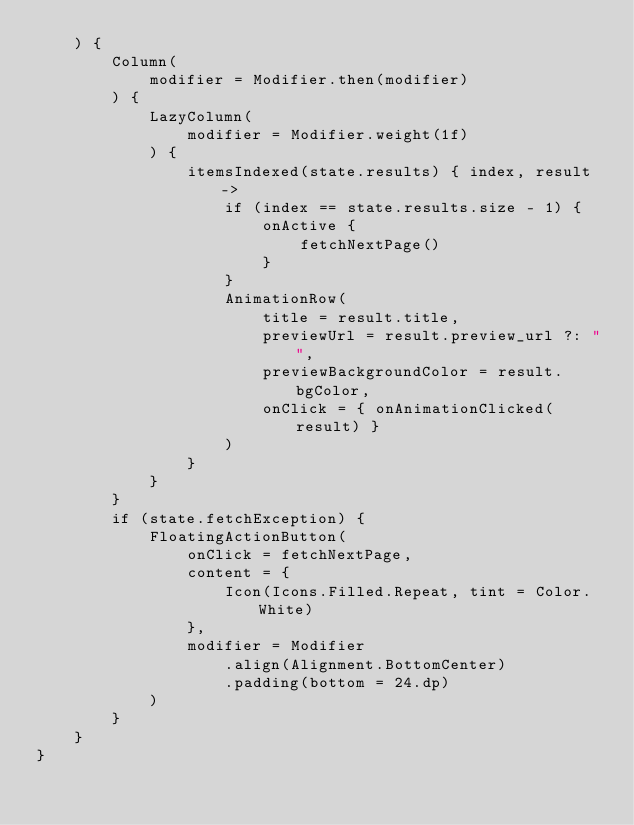<code> <loc_0><loc_0><loc_500><loc_500><_Kotlin_>    ) {
        Column(
            modifier = Modifier.then(modifier)
        ) {
            LazyColumn(
                modifier = Modifier.weight(1f)
            ) {
                itemsIndexed(state.results) { index, result ->
                    if (index == state.results.size - 1) {
                        onActive {
                            fetchNextPage()
                        }
                    }
                    AnimationRow(
                        title = result.title,
                        previewUrl = result.preview_url ?: "",
                        previewBackgroundColor = result.bgColor,
                        onClick = { onAnimationClicked(result) }
                    )
                }
            }
        }
        if (state.fetchException) {
            FloatingActionButton(
                onClick = fetchNextPage,
                content = {
                    Icon(Icons.Filled.Repeat, tint = Color.White)
                },
                modifier = Modifier
                    .align(Alignment.BottomCenter)
                    .padding(bottom = 24.dp)
            )
        }
    }
}</code> 